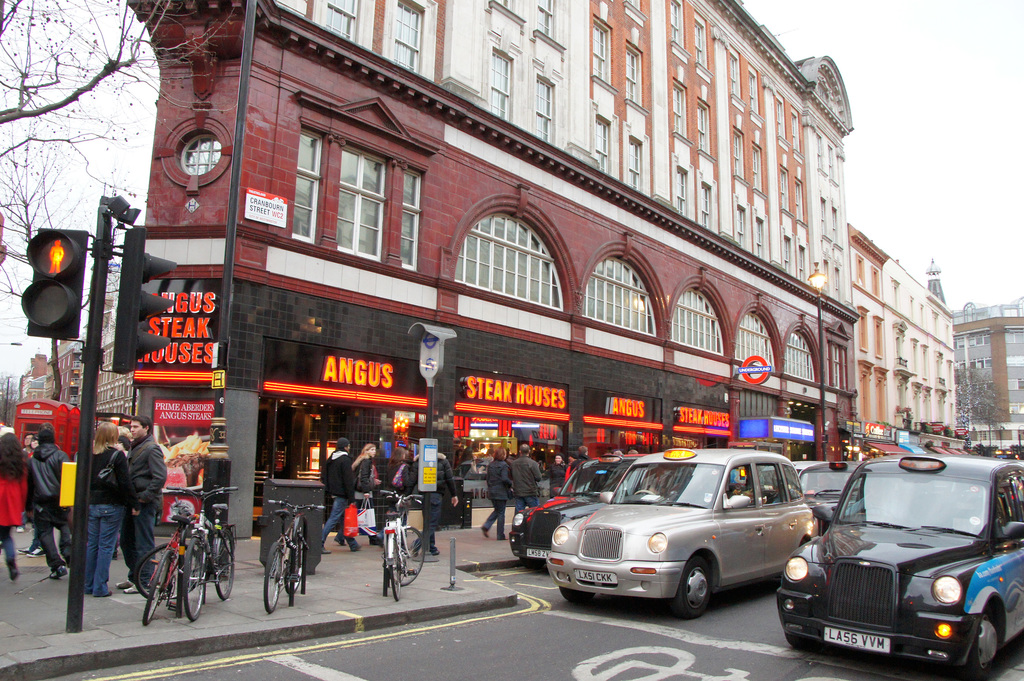Describe the atmosphere conveyed by the image and how the environment contributes to it. The image depicts a vibrant and bustling urban atmosphere, where the bright neon signs of the Angus Steak Houses add a lively contrast to the classic red-brick buildings. This blend of historical architecture with contemporary commercial signage, along with the dynamic movement of pedestrians and vehicles, creates a sense of a lively, bustling metropolitan life. 